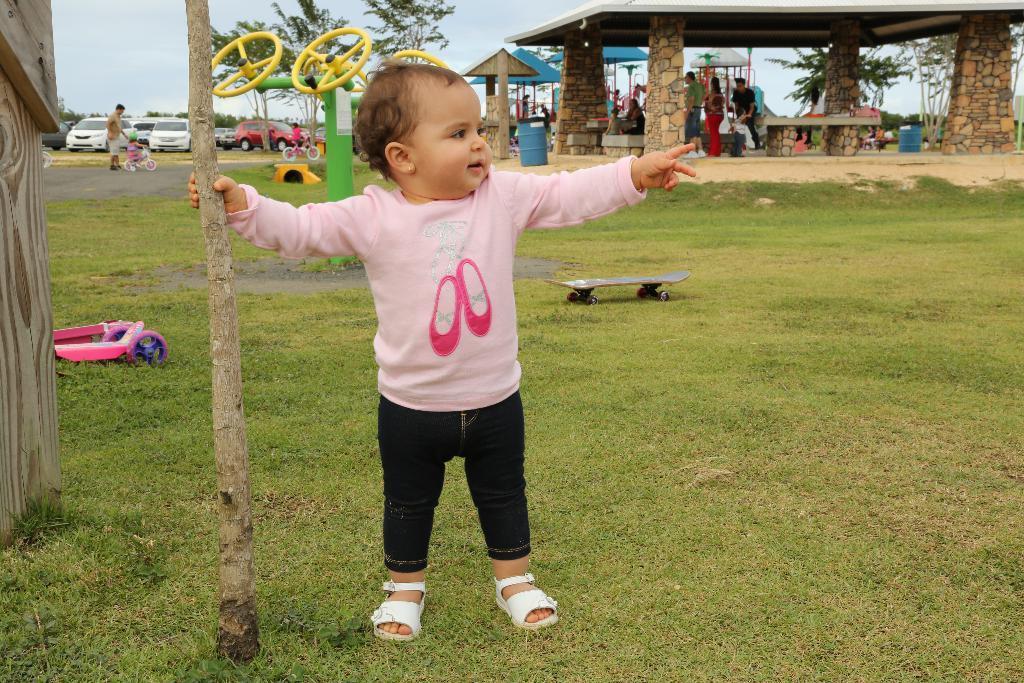In one or two sentences, can you explain what this image depicts? In this image in front there is a boy holding the wooden pole. Behind him there is a skateboard. At the bottom of the image there is grass on the surface. On the left side of the image there is some object. In the background of the image there are people cycling on the road. There are drums. There are tents. There are people standing under the roof. There are trees and sky. On the left side of the image there are cars. 